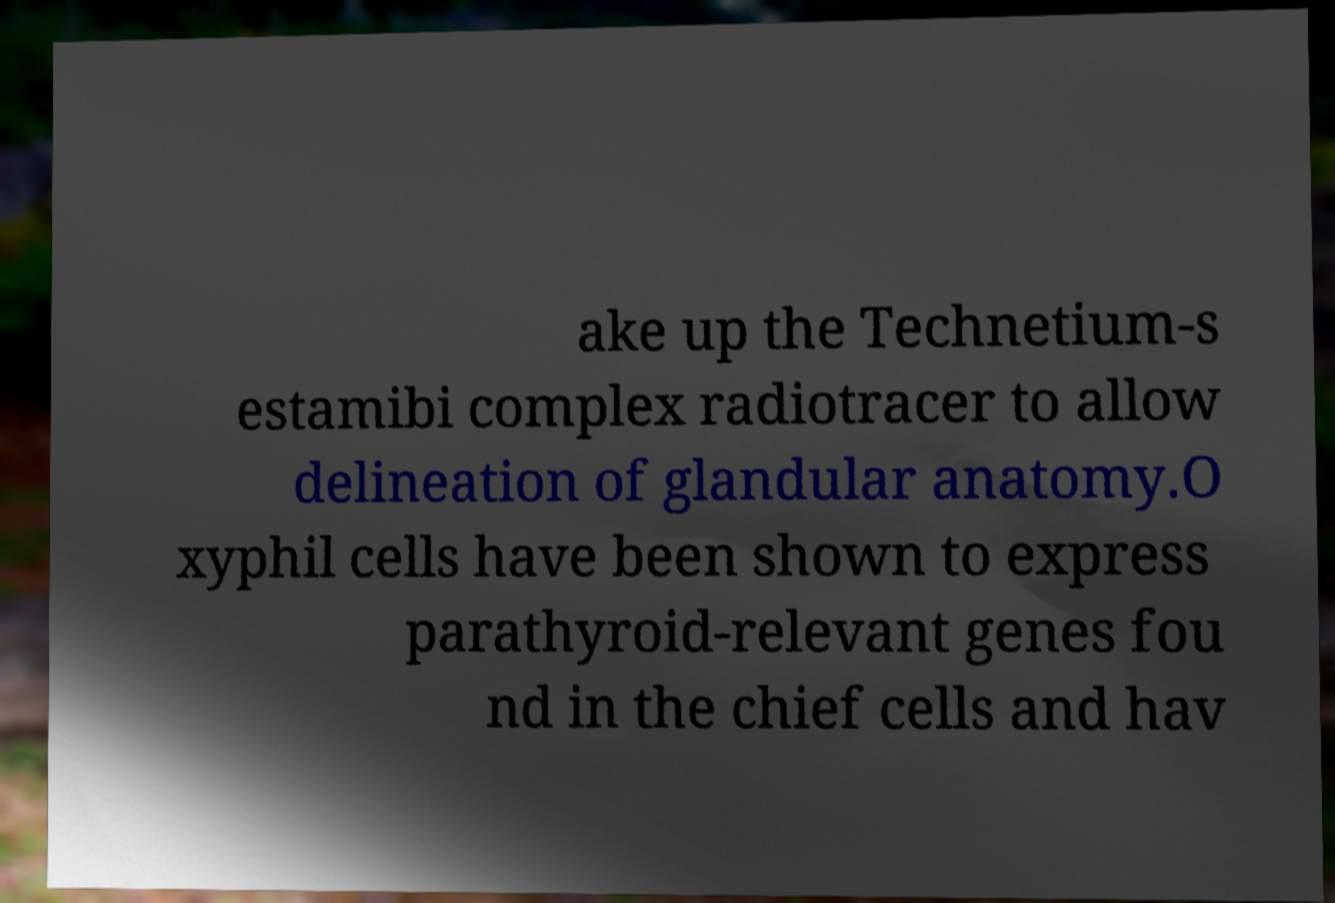Could you assist in decoding the text presented in this image and type it out clearly? ake up the Technetium-s estamibi complex radiotracer to allow delineation of glandular anatomy.O xyphil cells have been shown to express parathyroid-relevant genes fou nd in the chief cells and hav 